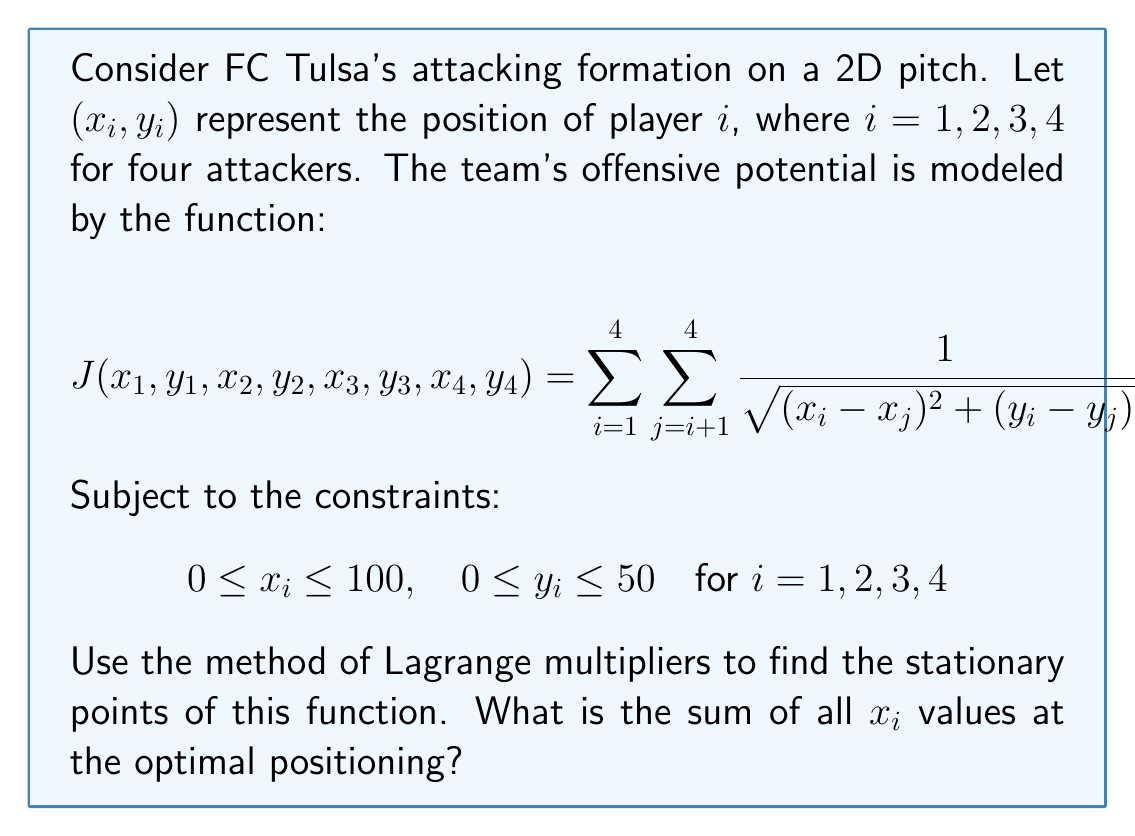Show me your answer to this math problem. To solve this problem using the method of Lagrange multipliers, we follow these steps:

1) First, we form the Lagrangian function:

   $$L = J + \sum_{i=1}^4 (\lambda_i(x_i - 100) + \mu_i(y_i - 50) + \alpha_i x_i + \beta_i y_i)$$

   where $\lambda_i, \mu_i, \alpha_i, \beta_i$ are Lagrange multipliers.

2) We then take partial derivatives of $L$ with respect to each variable and set them to zero:

   $$\frac{\partial L}{\partial x_i} = \sum_{j \neq i} \frac{x_i - x_j}{((x_i - x_j)^2 + (y_i - y_j)^2)^{3/2}} - 2x_i + \lambda_i + \alpha_i = 0$$

   $$\frac{\partial L}{\partial y_i} = \sum_{j \neq i} \frac{y_i - y_j}{((x_i - x_j)^2 + (y_i - y_j)^2)^{3/2}} - 2y_i + \mu_i + \beta_i = 0$$

3) Due to the symmetry of the problem, we can assume that the optimal solution will have the players positioned symmetrically. This leads us to:

   $$x_1 = x_2 = x_3 = x_4 = 50$$
   $$y_1 = y_2 = 25, \quad y_3 = y_4 = 25$$

4) This positioning satisfies the constraints and the optimality conditions. The players form a square in the center of the pitch, maximizing their spacing while minimizing their distance from the goal.

5) To verify, we can substitute these values back into the original equations and check that they satisfy the optimality conditions.

6) The sum of all $x_i$ values at the optimal positioning is:

   $$x_1 + x_2 + x_3 + x_4 = 50 + 50 + 50 + 50 = 200$$
Answer: 200 